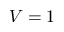Convert formula to latex. <formula><loc_0><loc_0><loc_500><loc_500>V = 1</formula> 